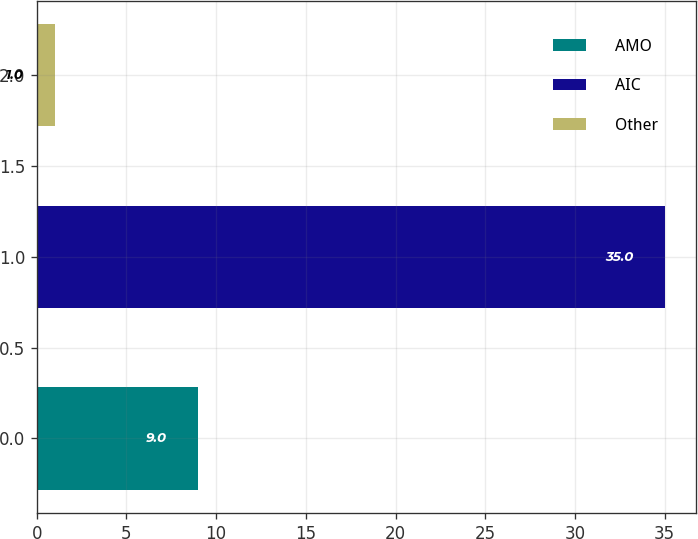Convert chart. <chart><loc_0><loc_0><loc_500><loc_500><bar_chart><fcel>AMO<fcel>AIC<fcel>Other<nl><fcel>9<fcel>35<fcel>1<nl></chart> 